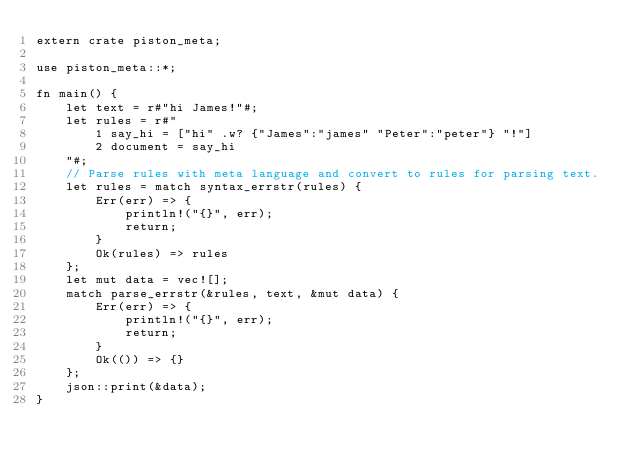Convert code to text. <code><loc_0><loc_0><loc_500><loc_500><_Rust_>extern crate piston_meta;

use piston_meta::*;

fn main() {
    let text = r#"hi James!"#;
    let rules = r#"
        1 say_hi = ["hi" .w? {"James":"james" "Peter":"peter"} "!"]
        2 document = say_hi
    "#;
    // Parse rules with meta language and convert to rules for parsing text.
    let rules = match syntax_errstr(rules) {
        Err(err) => {
            println!("{}", err);
            return;
        }
        Ok(rules) => rules
    };
    let mut data = vec![];
    match parse_errstr(&rules, text, &mut data) {
        Err(err) => {
            println!("{}", err);
            return;
        }
        Ok(()) => {}
    };
    json::print(&data);
}
</code> 